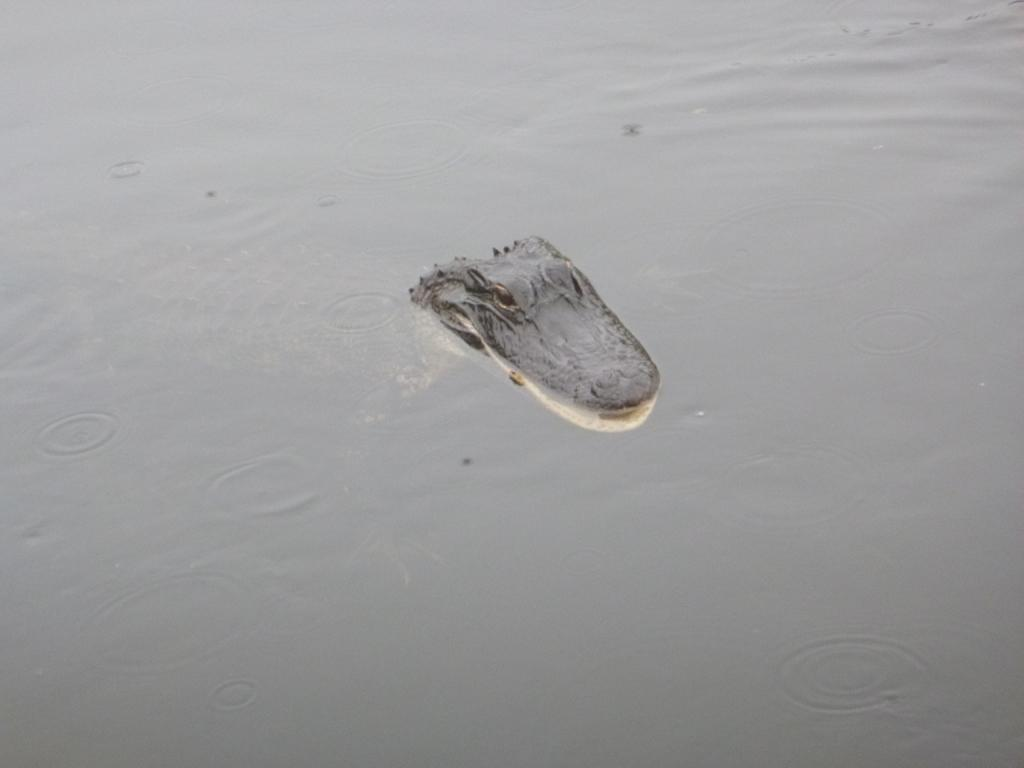What animal is present in the image? There is a crocodile in the image. What part of the crocodile can be seen? The crocodile's face is visible in the image. Where is the crocodile located? The crocodile is in water. What type of tomatoes can be seen growing near the crocodile in the image? There are no tomatoes present in the image; it features a crocodile in water. 